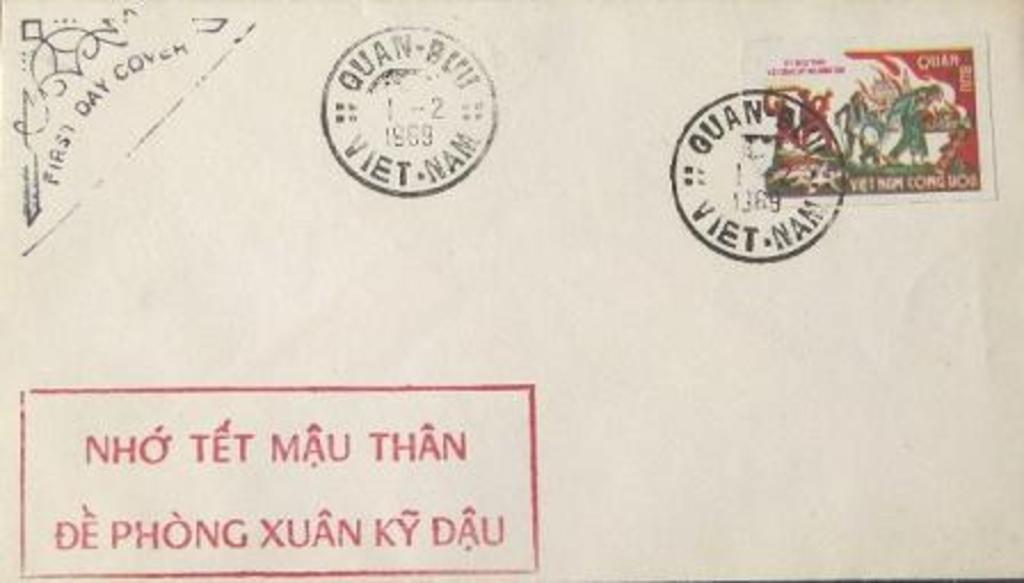<image>
Write a terse but informative summary of the picture. a post card with Vietnam post stamp on the right top corner 